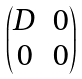<formula> <loc_0><loc_0><loc_500><loc_500>\begin{pmatrix} D & 0 \\ 0 & 0 \end{pmatrix}</formula> 